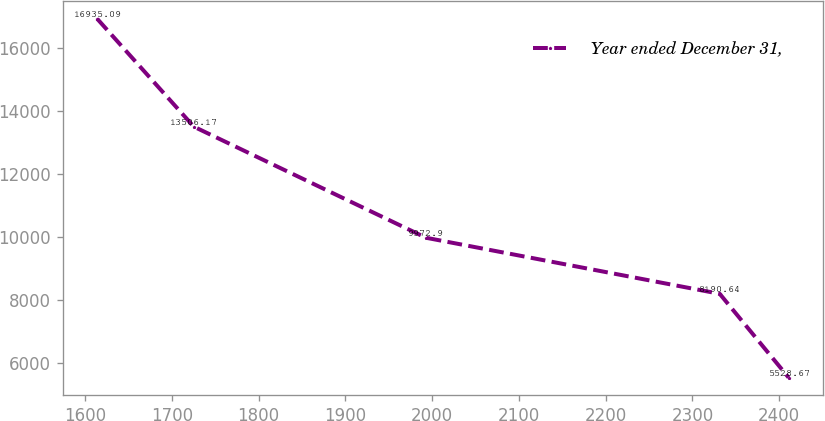Convert chart to OTSL. <chart><loc_0><loc_0><loc_500><loc_500><line_chart><ecel><fcel>Year ended December 31,<nl><fcel>1614.14<fcel>16935.1<nl><fcel>1725.42<fcel>13506.2<nl><fcel>1993.03<fcel>9972.9<nl><fcel>2331.44<fcel>8190.64<nl><fcel>2410.8<fcel>5528.67<nl></chart> 